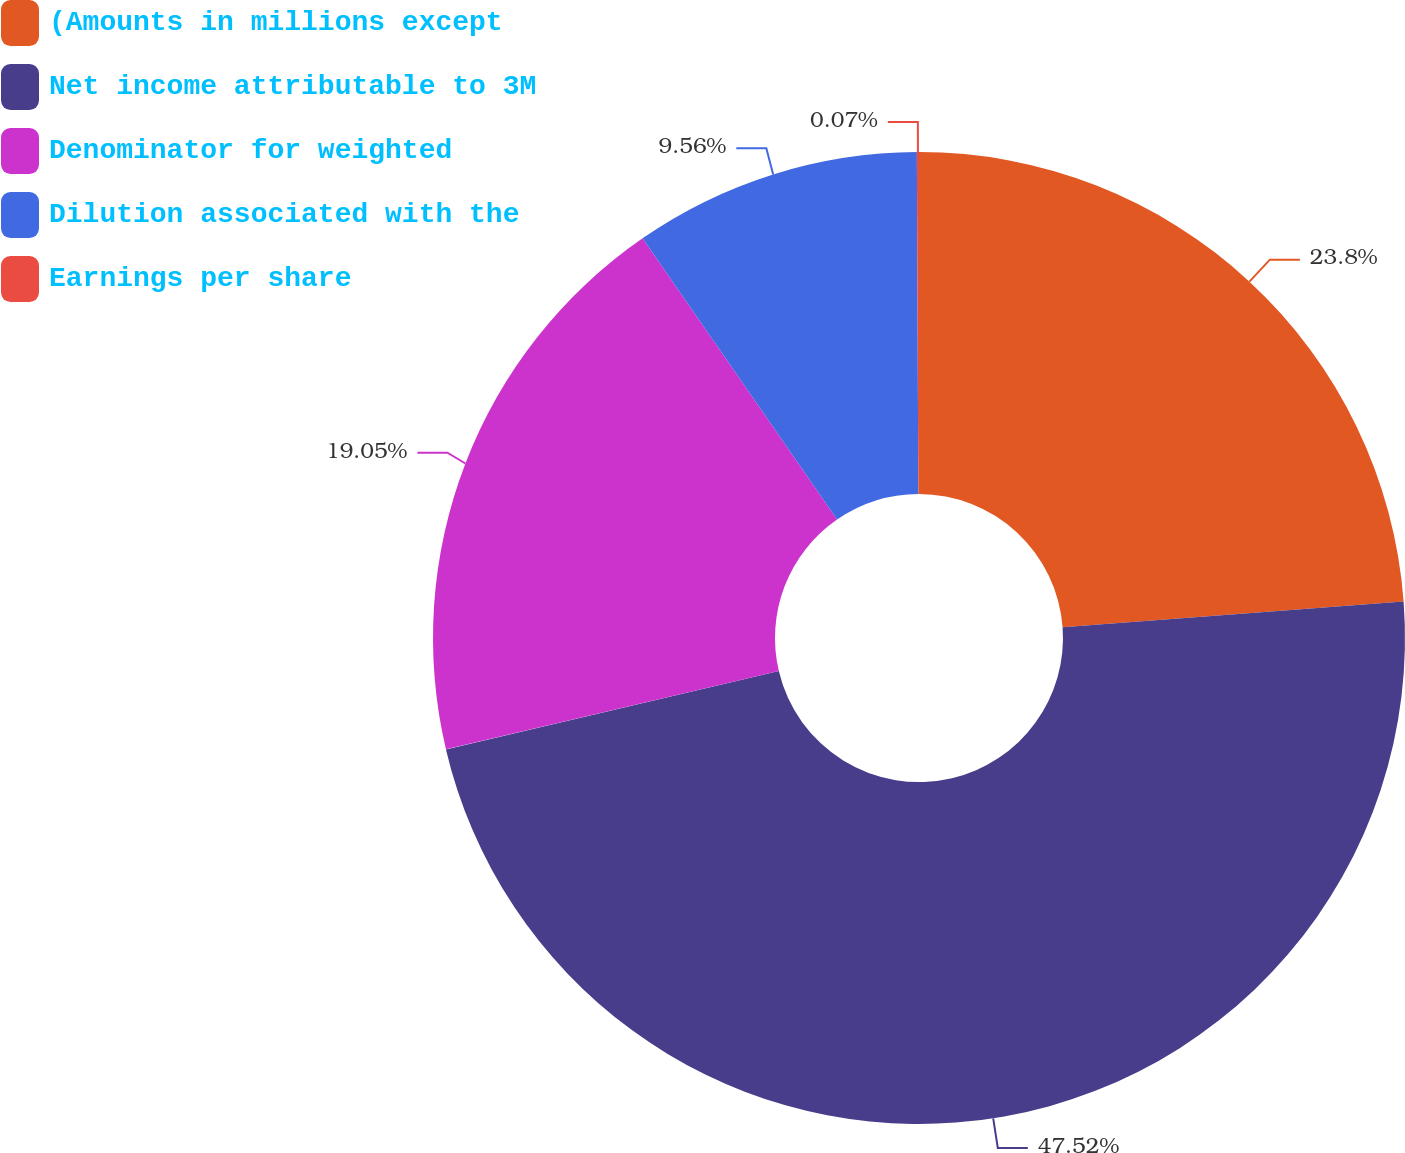Convert chart to OTSL. <chart><loc_0><loc_0><loc_500><loc_500><pie_chart><fcel>(Amounts in millions except<fcel>Net income attributable to 3M<fcel>Denominator for weighted<fcel>Dilution associated with the<fcel>Earnings per share<nl><fcel>23.8%<fcel>47.52%<fcel>19.05%<fcel>9.56%<fcel>0.07%<nl></chart> 